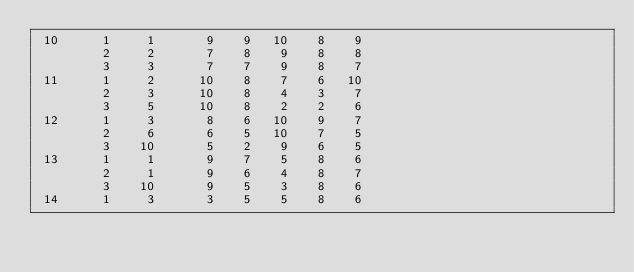Convert code to text. <code><loc_0><loc_0><loc_500><loc_500><_ObjectiveC_> 10      1     1       9    9   10    8    9
         2     2       7    8    9    8    8
         3     3       7    7    9    8    7
 11      1     2      10    8    7    6   10
         2     3      10    8    4    3    7
         3     5      10    8    2    2    6
 12      1     3       8    6   10    9    7
         2     6       6    5   10    7    5
         3    10       5    2    9    6    5
 13      1     1       9    7    5    8    6
         2     1       9    6    4    8    7
         3    10       9    5    3    8    6
 14      1     3       3    5    5    8    6</code> 